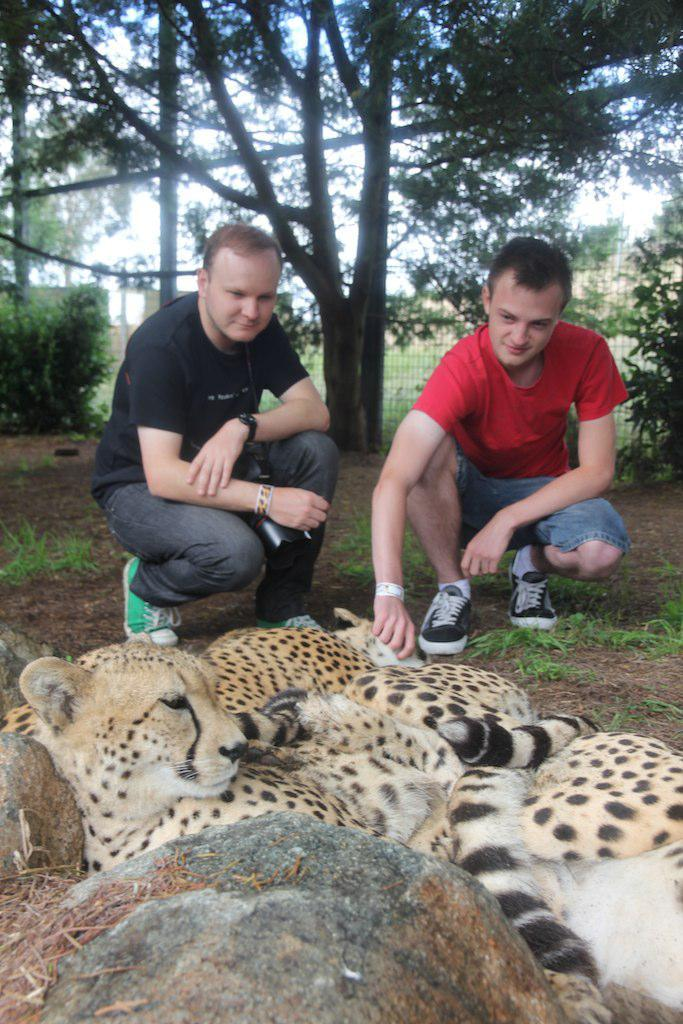What type of natural formation can be seen in the image? There are rocks in the image. What animals are behind the rocks? There are leopards behind the rocks. Can you describe the background of the image? There are two men on a land in the background, and there are trees present as well. What type of metal object is being carried by the goat in the image? There is no goat or metal object present in the image. What is the goat doing with the box in the image? There is no goat or box present in the image. 